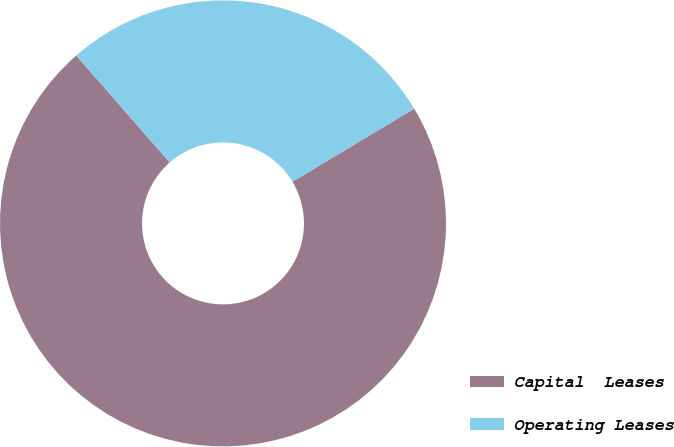Convert chart to OTSL. <chart><loc_0><loc_0><loc_500><loc_500><pie_chart><fcel>Capital  Leases<fcel>Operating Leases<nl><fcel>72.17%<fcel>27.83%<nl></chart> 